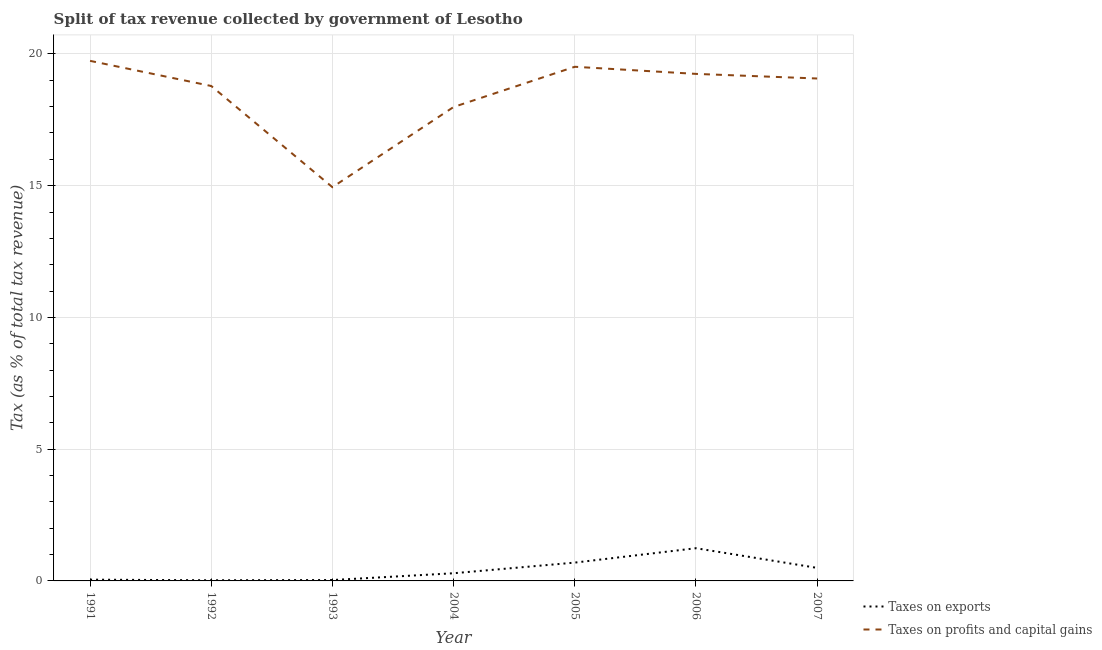How many different coloured lines are there?
Provide a succinct answer. 2. Is the number of lines equal to the number of legend labels?
Ensure brevity in your answer.  Yes. What is the percentage of revenue obtained from taxes on exports in 2004?
Make the answer very short. 0.29. Across all years, what is the maximum percentage of revenue obtained from taxes on profits and capital gains?
Keep it short and to the point. 19.74. Across all years, what is the minimum percentage of revenue obtained from taxes on exports?
Provide a succinct answer. 0.02. In which year was the percentage of revenue obtained from taxes on exports minimum?
Offer a very short reply. 1992. What is the total percentage of revenue obtained from taxes on exports in the graph?
Make the answer very short. 2.83. What is the difference between the percentage of revenue obtained from taxes on exports in 1991 and that in 1993?
Offer a very short reply. 0.01. What is the difference between the percentage of revenue obtained from taxes on profits and capital gains in 2007 and the percentage of revenue obtained from taxes on exports in 2005?
Offer a very short reply. 18.37. What is the average percentage of revenue obtained from taxes on profits and capital gains per year?
Provide a succinct answer. 18.47. In the year 2004, what is the difference between the percentage of revenue obtained from taxes on profits and capital gains and percentage of revenue obtained from taxes on exports?
Your answer should be compact. 17.69. In how many years, is the percentage of revenue obtained from taxes on exports greater than 3 %?
Your answer should be compact. 0. What is the ratio of the percentage of revenue obtained from taxes on exports in 1992 to that in 2006?
Offer a very short reply. 0.02. What is the difference between the highest and the second highest percentage of revenue obtained from taxes on exports?
Offer a very short reply. 0.55. What is the difference between the highest and the lowest percentage of revenue obtained from taxes on profits and capital gains?
Provide a succinct answer. 4.79. In how many years, is the percentage of revenue obtained from taxes on profits and capital gains greater than the average percentage of revenue obtained from taxes on profits and capital gains taken over all years?
Make the answer very short. 5. Does the percentage of revenue obtained from taxes on exports monotonically increase over the years?
Ensure brevity in your answer.  No. Is the percentage of revenue obtained from taxes on exports strictly greater than the percentage of revenue obtained from taxes on profits and capital gains over the years?
Your answer should be very brief. No. Is the percentage of revenue obtained from taxes on profits and capital gains strictly less than the percentage of revenue obtained from taxes on exports over the years?
Your response must be concise. No. What is the difference between two consecutive major ticks on the Y-axis?
Your answer should be compact. 5. Are the values on the major ticks of Y-axis written in scientific E-notation?
Offer a terse response. No. Does the graph contain grids?
Keep it short and to the point. Yes. How many legend labels are there?
Your response must be concise. 2. How are the legend labels stacked?
Give a very brief answer. Vertical. What is the title of the graph?
Offer a very short reply. Split of tax revenue collected by government of Lesotho. Does "Primary education" appear as one of the legend labels in the graph?
Make the answer very short. No. What is the label or title of the Y-axis?
Your response must be concise. Tax (as % of total tax revenue). What is the Tax (as % of total tax revenue) of Taxes on exports in 1991?
Your answer should be compact. 0.05. What is the Tax (as % of total tax revenue) of Taxes on profits and capital gains in 1991?
Offer a terse response. 19.74. What is the Tax (as % of total tax revenue) in Taxes on exports in 1992?
Your answer should be compact. 0.02. What is the Tax (as % of total tax revenue) in Taxes on profits and capital gains in 1992?
Give a very brief answer. 18.78. What is the Tax (as % of total tax revenue) of Taxes on exports in 1993?
Make the answer very short. 0.03. What is the Tax (as % of total tax revenue) of Taxes on profits and capital gains in 1993?
Give a very brief answer. 14.94. What is the Tax (as % of total tax revenue) in Taxes on exports in 2004?
Keep it short and to the point. 0.29. What is the Tax (as % of total tax revenue) in Taxes on profits and capital gains in 2004?
Offer a very short reply. 17.99. What is the Tax (as % of total tax revenue) in Taxes on exports in 2005?
Ensure brevity in your answer.  0.7. What is the Tax (as % of total tax revenue) of Taxes on profits and capital gains in 2005?
Provide a succinct answer. 19.51. What is the Tax (as % of total tax revenue) of Taxes on exports in 2006?
Offer a very short reply. 1.24. What is the Tax (as % of total tax revenue) of Taxes on profits and capital gains in 2006?
Offer a very short reply. 19.24. What is the Tax (as % of total tax revenue) in Taxes on exports in 2007?
Make the answer very short. 0.49. What is the Tax (as % of total tax revenue) of Taxes on profits and capital gains in 2007?
Ensure brevity in your answer.  19.07. Across all years, what is the maximum Tax (as % of total tax revenue) in Taxes on exports?
Keep it short and to the point. 1.24. Across all years, what is the maximum Tax (as % of total tax revenue) of Taxes on profits and capital gains?
Ensure brevity in your answer.  19.74. Across all years, what is the minimum Tax (as % of total tax revenue) in Taxes on exports?
Your response must be concise. 0.02. Across all years, what is the minimum Tax (as % of total tax revenue) in Taxes on profits and capital gains?
Offer a very short reply. 14.94. What is the total Tax (as % of total tax revenue) of Taxes on exports in the graph?
Provide a succinct answer. 2.83. What is the total Tax (as % of total tax revenue) in Taxes on profits and capital gains in the graph?
Provide a succinct answer. 129.27. What is the difference between the Tax (as % of total tax revenue) of Taxes on exports in 1991 and that in 1992?
Your answer should be compact. 0.02. What is the difference between the Tax (as % of total tax revenue) of Taxes on profits and capital gains in 1991 and that in 1992?
Ensure brevity in your answer.  0.95. What is the difference between the Tax (as % of total tax revenue) of Taxes on exports in 1991 and that in 1993?
Provide a succinct answer. 0.01. What is the difference between the Tax (as % of total tax revenue) in Taxes on profits and capital gains in 1991 and that in 1993?
Your answer should be very brief. 4.79. What is the difference between the Tax (as % of total tax revenue) in Taxes on exports in 1991 and that in 2004?
Make the answer very short. -0.24. What is the difference between the Tax (as % of total tax revenue) of Taxes on profits and capital gains in 1991 and that in 2004?
Give a very brief answer. 1.75. What is the difference between the Tax (as % of total tax revenue) in Taxes on exports in 1991 and that in 2005?
Your response must be concise. -0.65. What is the difference between the Tax (as % of total tax revenue) of Taxes on profits and capital gains in 1991 and that in 2005?
Your response must be concise. 0.23. What is the difference between the Tax (as % of total tax revenue) of Taxes on exports in 1991 and that in 2006?
Your answer should be compact. -1.19. What is the difference between the Tax (as % of total tax revenue) in Taxes on profits and capital gains in 1991 and that in 2006?
Give a very brief answer. 0.49. What is the difference between the Tax (as % of total tax revenue) of Taxes on exports in 1991 and that in 2007?
Keep it short and to the point. -0.45. What is the difference between the Tax (as % of total tax revenue) in Taxes on profits and capital gains in 1991 and that in 2007?
Your answer should be very brief. 0.67. What is the difference between the Tax (as % of total tax revenue) in Taxes on exports in 1992 and that in 1993?
Your response must be concise. -0.01. What is the difference between the Tax (as % of total tax revenue) of Taxes on profits and capital gains in 1992 and that in 1993?
Ensure brevity in your answer.  3.84. What is the difference between the Tax (as % of total tax revenue) of Taxes on exports in 1992 and that in 2004?
Make the answer very short. -0.27. What is the difference between the Tax (as % of total tax revenue) in Taxes on profits and capital gains in 1992 and that in 2004?
Your response must be concise. 0.8. What is the difference between the Tax (as % of total tax revenue) of Taxes on exports in 1992 and that in 2005?
Ensure brevity in your answer.  -0.67. What is the difference between the Tax (as % of total tax revenue) in Taxes on profits and capital gains in 1992 and that in 2005?
Your answer should be very brief. -0.73. What is the difference between the Tax (as % of total tax revenue) in Taxes on exports in 1992 and that in 2006?
Offer a very short reply. -1.22. What is the difference between the Tax (as % of total tax revenue) of Taxes on profits and capital gains in 1992 and that in 2006?
Your answer should be very brief. -0.46. What is the difference between the Tax (as % of total tax revenue) of Taxes on exports in 1992 and that in 2007?
Your answer should be very brief. -0.47. What is the difference between the Tax (as % of total tax revenue) of Taxes on profits and capital gains in 1992 and that in 2007?
Offer a terse response. -0.28. What is the difference between the Tax (as % of total tax revenue) in Taxes on exports in 1993 and that in 2004?
Give a very brief answer. -0.26. What is the difference between the Tax (as % of total tax revenue) in Taxes on profits and capital gains in 1993 and that in 2004?
Provide a succinct answer. -3.04. What is the difference between the Tax (as % of total tax revenue) in Taxes on exports in 1993 and that in 2005?
Keep it short and to the point. -0.66. What is the difference between the Tax (as % of total tax revenue) in Taxes on profits and capital gains in 1993 and that in 2005?
Provide a short and direct response. -4.57. What is the difference between the Tax (as % of total tax revenue) of Taxes on exports in 1993 and that in 2006?
Give a very brief answer. -1.21. What is the difference between the Tax (as % of total tax revenue) in Taxes on profits and capital gains in 1993 and that in 2006?
Offer a terse response. -4.3. What is the difference between the Tax (as % of total tax revenue) of Taxes on exports in 1993 and that in 2007?
Keep it short and to the point. -0.46. What is the difference between the Tax (as % of total tax revenue) in Taxes on profits and capital gains in 1993 and that in 2007?
Make the answer very short. -4.12. What is the difference between the Tax (as % of total tax revenue) of Taxes on exports in 2004 and that in 2005?
Provide a short and direct response. -0.4. What is the difference between the Tax (as % of total tax revenue) in Taxes on profits and capital gains in 2004 and that in 2005?
Keep it short and to the point. -1.53. What is the difference between the Tax (as % of total tax revenue) in Taxes on exports in 2004 and that in 2006?
Ensure brevity in your answer.  -0.95. What is the difference between the Tax (as % of total tax revenue) in Taxes on profits and capital gains in 2004 and that in 2006?
Offer a terse response. -1.26. What is the difference between the Tax (as % of total tax revenue) in Taxes on exports in 2004 and that in 2007?
Your answer should be very brief. -0.2. What is the difference between the Tax (as % of total tax revenue) in Taxes on profits and capital gains in 2004 and that in 2007?
Provide a short and direct response. -1.08. What is the difference between the Tax (as % of total tax revenue) in Taxes on exports in 2005 and that in 2006?
Make the answer very short. -0.55. What is the difference between the Tax (as % of total tax revenue) in Taxes on profits and capital gains in 2005 and that in 2006?
Ensure brevity in your answer.  0.27. What is the difference between the Tax (as % of total tax revenue) in Taxes on exports in 2005 and that in 2007?
Your response must be concise. 0.2. What is the difference between the Tax (as % of total tax revenue) in Taxes on profits and capital gains in 2005 and that in 2007?
Your response must be concise. 0.44. What is the difference between the Tax (as % of total tax revenue) of Taxes on exports in 2006 and that in 2007?
Your answer should be compact. 0.75. What is the difference between the Tax (as % of total tax revenue) in Taxes on profits and capital gains in 2006 and that in 2007?
Ensure brevity in your answer.  0.17. What is the difference between the Tax (as % of total tax revenue) in Taxes on exports in 1991 and the Tax (as % of total tax revenue) in Taxes on profits and capital gains in 1992?
Your response must be concise. -18.73. What is the difference between the Tax (as % of total tax revenue) of Taxes on exports in 1991 and the Tax (as % of total tax revenue) of Taxes on profits and capital gains in 1993?
Give a very brief answer. -14.89. What is the difference between the Tax (as % of total tax revenue) of Taxes on exports in 1991 and the Tax (as % of total tax revenue) of Taxes on profits and capital gains in 2004?
Keep it short and to the point. -17.94. What is the difference between the Tax (as % of total tax revenue) of Taxes on exports in 1991 and the Tax (as % of total tax revenue) of Taxes on profits and capital gains in 2005?
Make the answer very short. -19.46. What is the difference between the Tax (as % of total tax revenue) in Taxes on exports in 1991 and the Tax (as % of total tax revenue) in Taxes on profits and capital gains in 2006?
Ensure brevity in your answer.  -19.19. What is the difference between the Tax (as % of total tax revenue) in Taxes on exports in 1991 and the Tax (as % of total tax revenue) in Taxes on profits and capital gains in 2007?
Offer a terse response. -19.02. What is the difference between the Tax (as % of total tax revenue) of Taxes on exports in 1992 and the Tax (as % of total tax revenue) of Taxes on profits and capital gains in 1993?
Keep it short and to the point. -14.92. What is the difference between the Tax (as % of total tax revenue) of Taxes on exports in 1992 and the Tax (as % of total tax revenue) of Taxes on profits and capital gains in 2004?
Make the answer very short. -17.96. What is the difference between the Tax (as % of total tax revenue) in Taxes on exports in 1992 and the Tax (as % of total tax revenue) in Taxes on profits and capital gains in 2005?
Give a very brief answer. -19.49. What is the difference between the Tax (as % of total tax revenue) of Taxes on exports in 1992 and the Tax (as % of total tax revenue) of Taxes on profits and capital gains in 2006?
Your response must be concise. -19.22. What is the difference between the Tax (as % of total tax revenue) in Taxes on exports in 1992 and the Tax (as % of total tax revenue) in Taxes on profits and capital gains in 2007?
Offer a very short reply. -19.04. What is the difference between the Tax (as % of total tax revenue) in Taxes on exports in 1993 and the Tax (as % of total tax revenue) in Taxes on profits and capital gains in 2004?
Your response must be concise. -17.95. What is the difference between the Tax (as % of total tax revenue) of Taxes on exports in 1993 and the Tax (as % of total tax revenue) of Taxes on profits and capital gains in 2005?
Your answer should be very brief. -19.48. What is the difference between the Tax (as % of total tax revenue) of Taxes on exports in 1993 and the Tax (as % of total tax revenue) of Taxes on profits and capital gains in 2006?
Offer a very short reply. -19.21. What is the difference between the Tax (as % of total tax revenue) in Taxes on exports in 1993 and the Tax (as % of total tax revenue) in Taxes on profits and capital gains in 2007?
Your response must be concise. -19.03. What is the difference between the Tax (as % of total tax revenue) in Taxes on exports in 2004 and the Tax (as % of total tax revenue) in Taxes on profits and capital gains in 2005?
Offer a terse response. -19.22. What is the difference between the Tax (as % of total tax revenue) of Taxes on exports in 2004 and the Tax (as % of total tax revenue) of Taxes on profits and capital gains in 2006?
Offer a very short reply. -18.95. What is the difference between the Tax (as % of total tax revenue) of Taxes on exports in 2004 and the Tax (as % of total tax revenue) of Taxes on profits and capital gains in 2007?
Give a very brief answer. -18.78. What is the difference between the Tax (as % of total tax revenue) in Taxes on exports in 2005 and the Tax (as % of total tax revenue) in Taxes on profits and capital gains in 2006?
Ensure brevity in your answer.  -18.55. What is the difference between the Tax (as % of total tax revenue) in Taxes on exports in 2005 and the Tax (as % of total tax revenue) in Taxes on profits and capital gains in 2007?
Provide a succinct answer. -18.37. What is the difference between the Tax (as % of total tax revenue) of Taxes on exports in 2006 and the Tax (as % of total tax revenue) of Taxes on profits and capital gains in 2007?
Ensure brevity in your answer.  -17.83. What is the average Tax (as % of total tax revenue) of Taxes on exports per year?
Your response must be concise. 0.4. What is the average Tax (as % of total tax revenue) of Taxes on profits and capital gains per year?
Offer a very short reply. 18.47. In the year 1991, what is the difference between the Tax (as % of total tax revenue) in Taxes on exports and Tax (as % of total tax revenue) in Taxes on profits and capital gains?
Your answer should be very brief. -19.69. In the year 1992, what is the difference between the Tax (as % of total tax revenue) of Taxes on exports and Tax (as % of total tax revenue) of Taxes on profits and capital gains?
Keep it short and to the point. -18.76. In the year 1993, what is the difference between the Tax (as % of total tax revenue) of Taxes on exports and Tax (as % of total tax revenue) of Taxes on profits and capital gains?
Ensure brevity in your answer.  -14.91. In the year 2004, what is the difference between the Tax (as % of total tax revenue) in Taxes on exports and Tax (as % of total tax revenue) in Taxes on profits and capital gains?
Offer a terse response. -17.69. In the year 2005, what is the difference between the Tax (as % of total tax revenue) of Taxes on exports and Tax (as % of total tax revenue) of Taxes on profits and capital gains?
Provide a short and direct response. -18.82. In the year 2006, what is the difference between the Tax (as % of total tax revenue) in Taxes on exports and Tax (as % of total tax revenue) in Taxes on profits and capital gains?
Keep it short and to the point. -18. In the year 2007, what is the difference between the Tax (as % of total tax revenue) of Taxes on exports and Tax (as % of total tax revenue) of Taxes on profits and capital gains?
Provide a succinct answer. -18.57. What is the ratio of the Tax (as % of total tax revenue) in Taxes on exports in 1991 to that in 1992?
Give a very brief answer. 1.97. What is the ratio of the Tax (as % of total tax revenue) of Taxes on profits and capital gains in 1991 to that in 1992?
Your answer should be compact. 1.05. What is the ratio of the Tax (as % of total tax revenue) of Taxes on exports in 1991 to that in 1993?
Your response must be concise. 1.44. What is the ratio of the Tax (as % of total tax revenue) in Taxes on profits and capital gains in 1991 to that in 1993?
Provide a short and direct response. 1.32. What is the ratio of the Tax (as % of total tax revenue) of Taxes on exports in 1991 to that in 2004?
Your answer should be compact. 0.16. What is the ratio of the Tax (as % of total tax revenue) in Taxes on profits and capital gains in 1991 to that in 2004?
Your response must be concise. 1.1. What is the ratio of the Tax (as % of total tax revenue) in Taxes on exports in 1991 to that in 2005?
Make the answer very short. 0.07. What is the ratio of the Tax (as % of total tax revenue) of Taxes on profits and capital gains in 1991 to that in 2005?
Give a very brief answer. 1.01. What is the ratio of the Tax (as % of total tax revenue) of Taxes on exports in 1991 to that in 2006?
Ensure brevity in your answer.  0.04. What is the ratio of the Tax (as % of total tax revenue) in Taxes on profits and capital gains in 1991 to that in 2006?
Make the answer very short. 1.03. What is the ratio of the Tax (as % of total tax revenue) of Taxes on exports in 1991 to that in 2007?
Provide a short and direct response. 0.1. What is the ratio of the Tax (as % of total tax revenue) of Taxes on profits and capital gains in 1991 to that in 2007?
Offer a terse response. 1.04. What is the ratio of the Tax (as % of total tax revenue) of Taxes on exports in 1992 to that in 1993?
Your answer should be compact. 0.73. What is the ratio of the Tax (as % of total tax revenue) in Taxes on profits and capital gains in 1992 to that in 1993?
Your response must be concise. 1.26. What is the ratio of the Tax (as % of total tax revenue) of Taxes on exports in 1992 to that in 2004?
Your answer should be compact. 0.08. What is the ratio of the Tax (as % of total tax revenue) of Taxes on profits and capital gains in 1992 to that in 2004?
Offer a very short reply. 1.04. What is the ratio of the Tax (as % of total tax revenue) in Taxes on exports in 1992 to that in 2005?
Keep it short and to the point. 0.03. What is the ratio of the Tax (as % of total tax revenue) in Taxes on profits and capital gains in 1992 to that in 2005?
Keep it short and to the point. 0.96. What is the ratio of the Tax (as % of total tax revenue) in Taxes on exports in 1992 to that in 2006?
Offer a very short reply. 0.02. What is the ratio of the Tax (as % of total tax revenue) in Taxes on profits and capital gains in 1992 to that in 2006?
Provide a short and direct response. 0.98. What is the ratio of the Tax (as % of total tax revenue) in Taxes on exports in 1992 to that in 2007?
Provide a succinct answer. 0.05. What is the ratio of the Tax (as % of total tax revenue) in Taxes on profits and capital gains in 1992 to that in 2007?
Offer a terse response. 0.99. What is the ratio of the Tax (as % of total tax revenue) in Taxes on exports in 1993 to that in 2004?
Your answer should be compact. 0.11. What is the ratio of the Tax (as % of total tax revenue) of Taxes on profits and capital gains in 1993 to that in 2004?
Your response must be concise. 0.83. What is the ratio of the Tax (as % of total tax revenue) in Taxes on exports in 1993 to that in 2005?
Your answer should be compact. 0.05. What is the ratio of the Tax (as % of total tax revenue) in Taxes on profits and capital gains in 1993 to that in 2005?
Make the answer very short. 0.77. What is the ratio of the Tax (as % of total tax revenue) of Taxes on exports in 1993 to that in 2006?
Your answer should be very brief. 0.03. What is the ratio of the Tax (as % of total tax revenue) in Taxes on profits and capital gains in 1993 to that in 2006?
Keep it short and to the point. 0.78. What is the ratio of the Tax (as % of total tax revenue) in Taxes on exports in 1993 to that in 2007?
Keep it short and to the point. 0.07. What is the ratio of the Tax (as % of total tax revenue) of Taxes on profits and capital gains in 1993 to that in 2007?
Make the answer very short. 0.78. What is the ratio of the Tax (as % of total tax revenue) in Taxes on exports in 2004 to that in 2005?
Provide a succinct answer. 0.42. What is the ratio of the Tax (as % of total tax revenue) of Taxes on profits and capital gains in 2004 to that in 2005?
Offer a very short reply. 0.92. What is the ratio of the Tax (as % of total tax revenue) in Taxes on exports in 2004 to that in 2006?
Provide a succinct answer. 0.23. What is the ratio of the Tax (as % of total tax revenue) in Taxes on profits and capital gains in 2004 to that in 2006?
Offer a very short reply. 0.93. What is the ratio of the Tax (as % of total tax revenue) in Taxes on exports in 2004 to that in 2007?
Provide a succinct answer. 0.59. What is the ratio of the Tax (as % of total tax revenue) of Taxes on profits and capital gains in 2004 to that in 2007?
Offer a terse response. 0.94. What is the ratio of the Tax (as % of total tax revenue) in Taxes on exports in 2005 to that in 2006?
Provide a short and direct response. 0.56. What is the ratio of the Tax (as % of total tax revenue) in Taxes on exports in 2005 to that in 2007?
Your answer should be very brief. 1.4. What is the ratio of the Tax (as % of total tax revenue) in Taxes on profits and capital gains in 2005 to that in 2007?
Give a very brief answer. 1.02. What is the ratio of the Tax (as % of total tax revenue) of Taxes on exports in 2006 to that in 2007?
Keep it short and to the point. 2.51. What is the ratio of the Tax (as % of total tax revenue) of Taxes on profits and capital gains in 2006 to that in 2007?
Provide a succinct answer. 1.01. What is the difference between the highest and the second highest Tax (as % of total tax revenue) of Taxes on exports?
Offer a very short reply. 0.55. What is the difference between the highest and the second highest Tax (as % of total tax revenue) of Taxes on profits and capital gains?
Keep it short and to the point. 0.23. What is the difference between the highest and the lowest Tax (as % of total tax revenue) in Taxes on exports?
Offer a terse response. 1.22. What is the difference between the highest and the lowest Tax (as % of total tax revenue) in Taxes on profits and capital gains?
Provide a short and direct response. 4.79. 